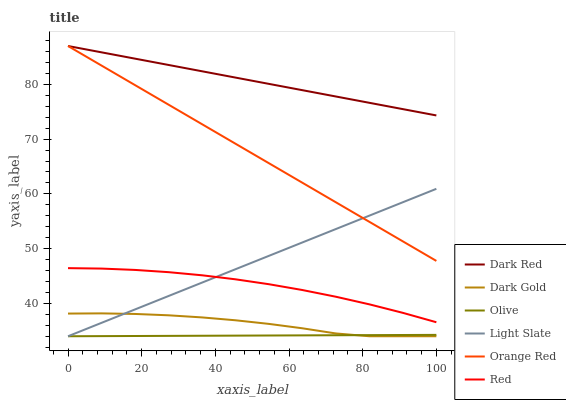Does Olive have the minimum area under the curve?
Answer yes or no. Yes. Does Dark Red have the maximum area under the curve?
Answer yes or no. Yes. Does Light Slate have the minimum area under the curve?
Answer yes or no. No. Does Light Slate have the maximum area under the curve?
Answer yes or no. No. Is Orange Red the smoothest?
Answer yes or no. Yes. Is Dark Gold the roughest?
Answer yes or no. Yes. Is Light Slate the smoothest?
Answer yes or no. No. Is Light Slate the roughest?
Answer yes or no. No. Does Dark Gold have the lowest value?
Answer yes or no. Yes. Does Dark Red have the lowest value?
Answer yes or no. No. Does Orange Red have the highest value?
Answer yes or no. Yes. Does Light Slate have the highest value?
Answer yes or no. No. Is Dark Gold less than Dark Red?
Answer yes or no. Yes. Is Orange Red greater than Dark Gold?
Answer yes or no. Yes. Does Light Slate intersect Red?
Answer yes or no. Yes. Is Light Slate less than Red?
Answer yes or no. No. Is Light Slate greater than Red?
Answer yes or no. No. Does Dark Gold intersect Dark Red?
Answer yes or no. No. 